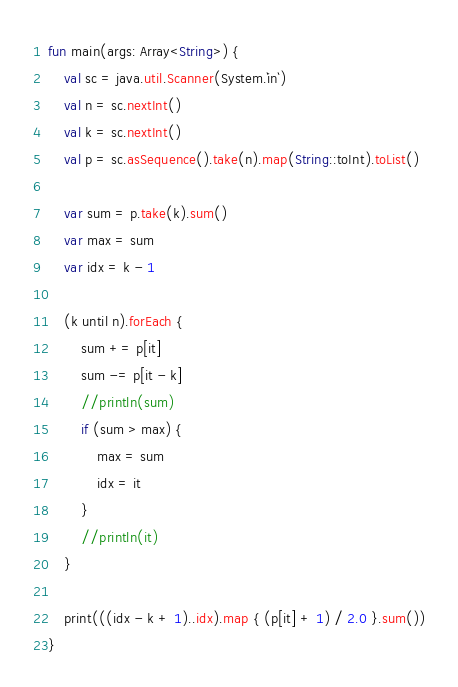Convert code to text. <code><loc_0><loc_0><loc_500><loc_500><_Kotlin_>fun main(args: Array<String>) {
    val sc = java.util.Scanner(System.`in`)
    val n = sc.nextInt()
    val k = sc.nextInt()
    val p = sc.asSequence().take(n).map(String::toInt).toList()

    var sum = p.take(k).sum()
    var max = sum
    var idx = k - 1

    (k until n).forEach {
        sum += p[it]
        sum -= p[it - k]
        //println(sum)
        if (sum > max) {
            max = sum
            idx = it
        }
        //println(it)
    }

    print(((idx - k + 1)..idx).map { (p[it] + 1) / 2.0 }.sum())
}
</code> 